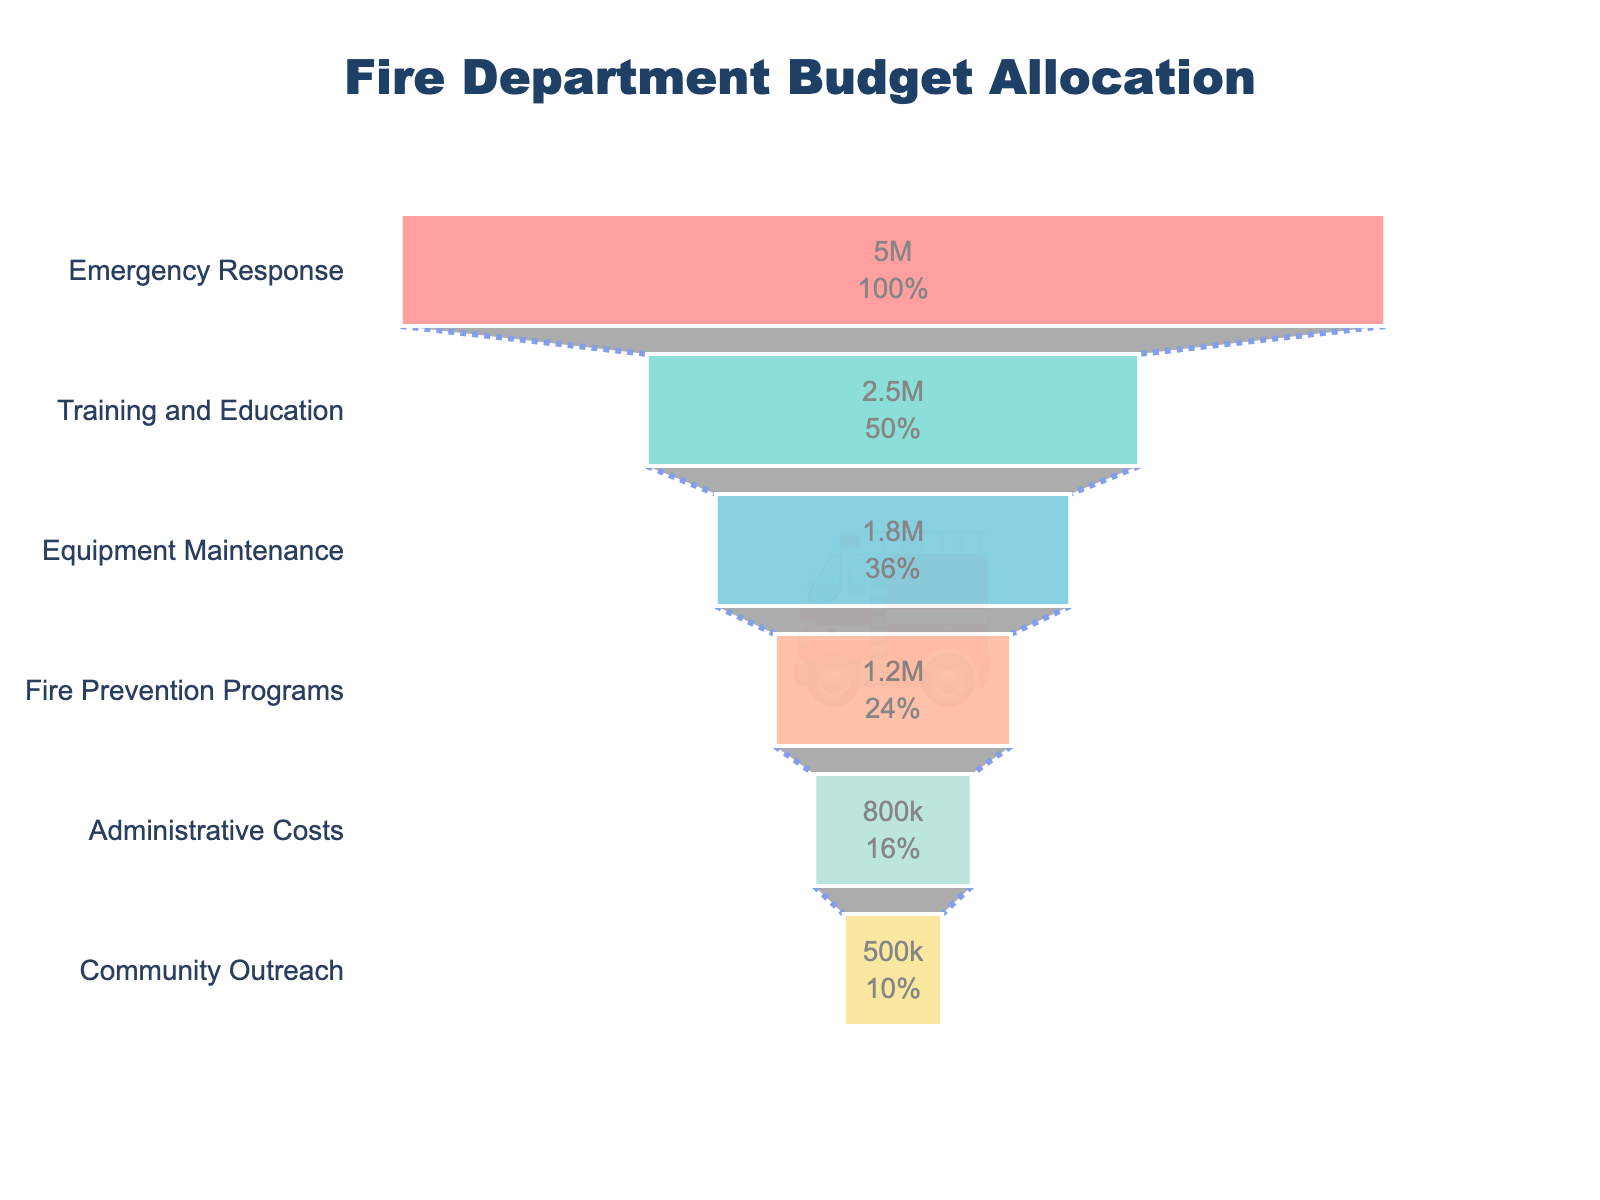What is the title of the figure? The title is usually displayed at the top of the chart and provides a description of what the figure represents. Here, it indicates the subject is related to the budget allocation of the fire department.
Answer: Fire Department Budget Allocation Which operational area receives the largest budget allocation? The funnel chart displays budget allocations from largest at the top to smallest at the bottom. The category at the top has the largest allocation.
Answer: Emergency Response How much budget is allocated to Training and Education? The funnel chart has text information within each section indicating both the dollar amount and percentage. Find the section labeled "Training and Education."
Answer: $2,500,000 Does Equipment Maintenance receive more budget allocation than Fire Prevention Programs? To compare, look at the position of both categories in the funnel chart. If Equipment Maintenance is positioned higher than Fire Prevention Programs, it receives more budget.
Answer: Yes What percentage of the total budget does Community Outreach receive? The funnel chart segments include both the dollar amount and percentage. Locate the Community Outreach section to find its percentage of the total budget.
Answer: 5% How much more is allocated to Administrative Costs compared to Community Outreach? Find the budget allocations for both categories and subtract the smaller allocation from the larger one ($800,000 - $500,000).
Answer: $300,000 What is the combined budget for Equipment Maintenance and Fire Prevention Programs? Add the budget allocations for both categories: $1,800,000 (Equipment Maintenance) + $1,200,000 (Fire Prevention Programs) = $3,000,000.
Answer: $3,000,000 If 30% of the total budget is allocated to Emergency Response, what is the total budget? The percentage value for Emergency Response is given as 30%. Use the formula: Total budget = Emergency Response budget / percentage = $5,000,000 / 0.30.
Answer: $16,666,667 Is the allocation for Fire Prevention Programs less than half of the allocation for Training and Education? Fire Prevention Programs' allocation is $1,200,000, and Training and Education is $2,500,000. Half of Training and Education is $1,250,000. Compare $1,200,000 and $1,250,000.
Answer: Yes Which color is used to represent Emergency Response in the funnel chart? The funnel chart uses different colors for each category. The color for Emergency Response can be identified by finding its segment at the top.
Answer: Red 